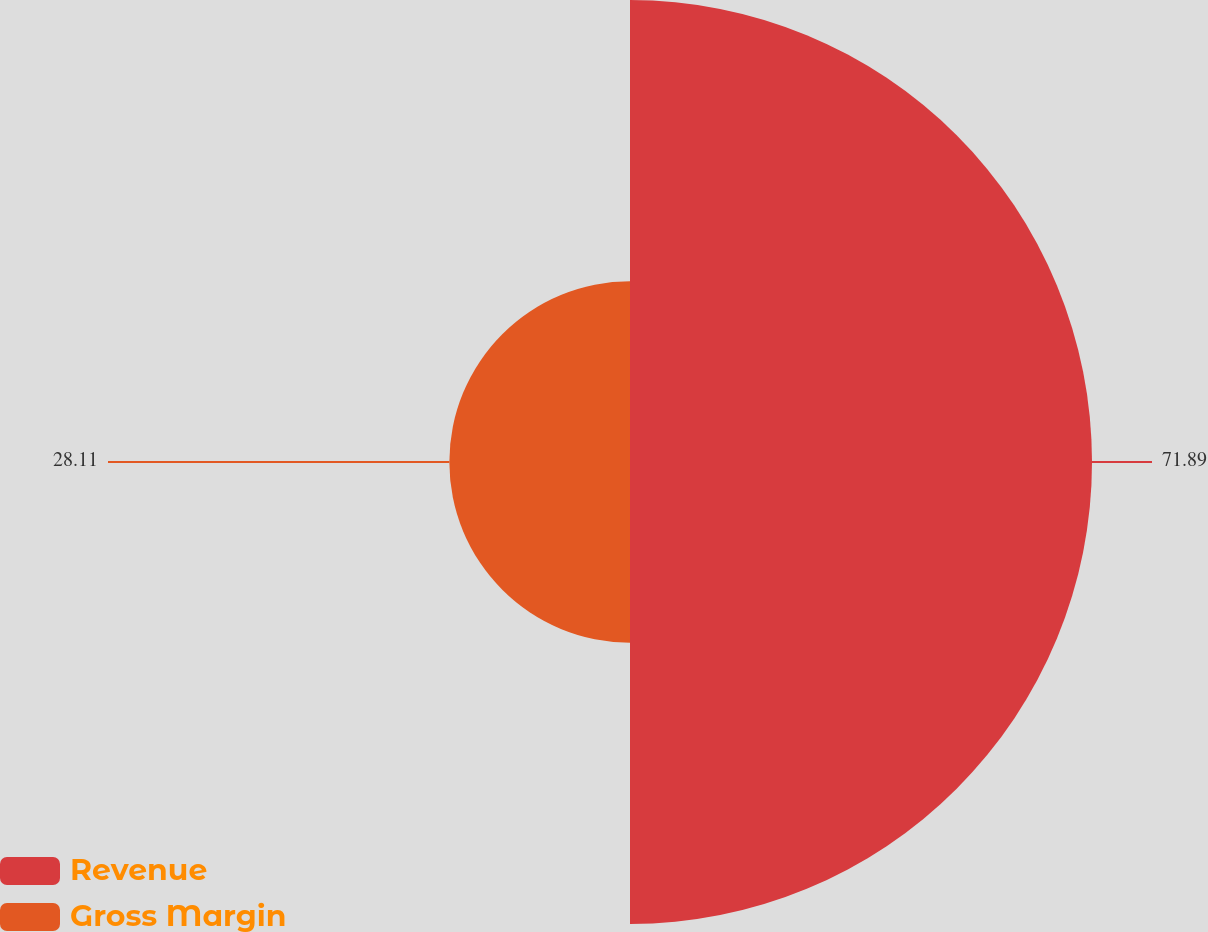Convert chart. <chart><loc_0><loc_0><loc_500><loc_500><pie_chart><fcel>Revenue<fcel>Gross Margin<nl><fcel>71.89%<fcel>28.11%<nl></chart> 